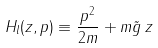<formula> <loc_0><loc_0><loc_500><loc_500>H _ { l } ( z , p ) \equiv \frac { p ^ { 2 } } { 2 m } + m \tilde { g } \, z</formula> 